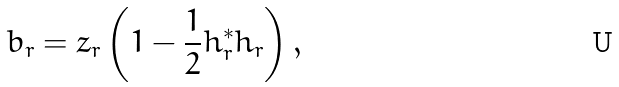Convert formula to latex. <formula><loc_0><loc_0><loc_500><loc_500>b _ { r } = z _ { r } \left ( 1 - \frac { 1 } { 2 } h ^ { * } _ { r } h _ { r } \right ) ,</formula> 